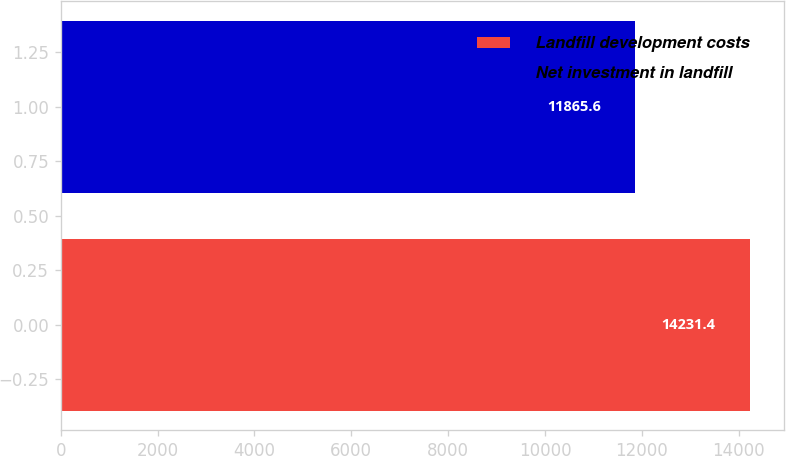<chart> <loc_0><loc_0><loc_500><loc_500><bar_chart><fcel>Landfill development costs<fcel>Net investment in landfill<nl><fcel>14231.4<fcel>11865.6<nl></chart> 